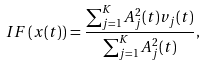Convert formula to latex. <formula><loc_0><loc_0><loc_500><loc_500>I F \left ( x ( t ) \right ) = \frac { \sum _ { j = 1 } ^ { K } A _ { j } ^ { 2 } ( t ) v _ { j } ( t ) } { \sum _ { j = 1 } ^ { K } A _ { j } ^ { 2 } ( t ) } ,</formula> 